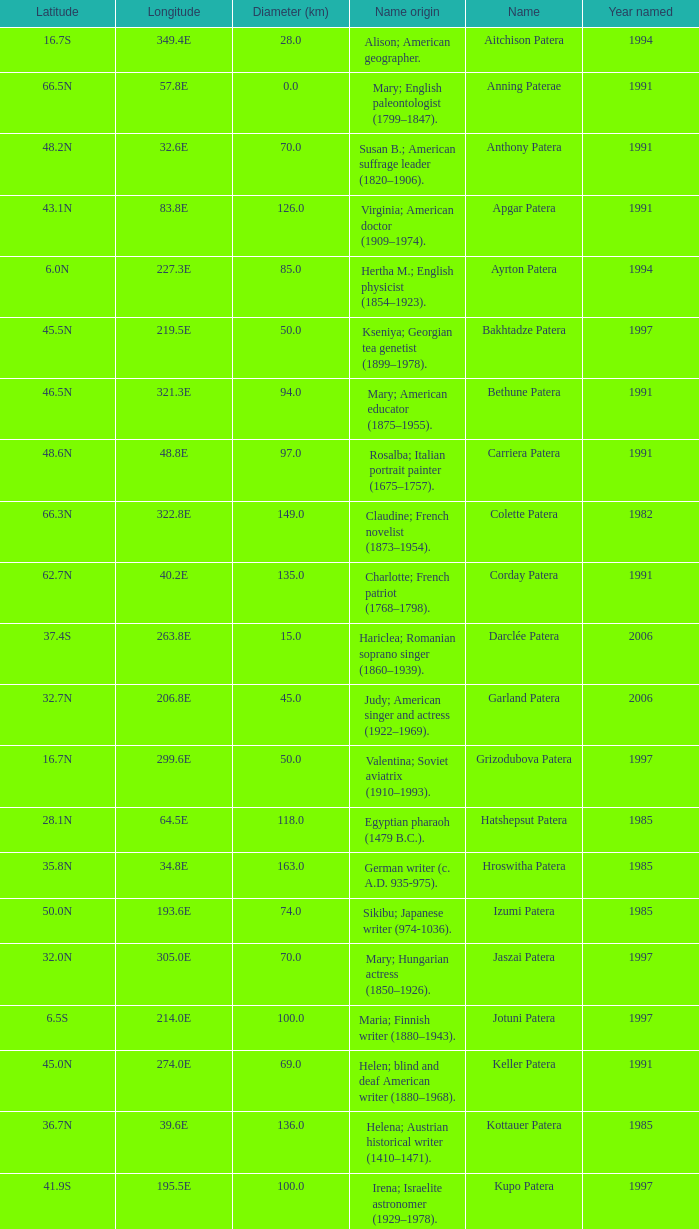What is  the diameter in km of the feature with a longitude of 40.2E?  135.0. 